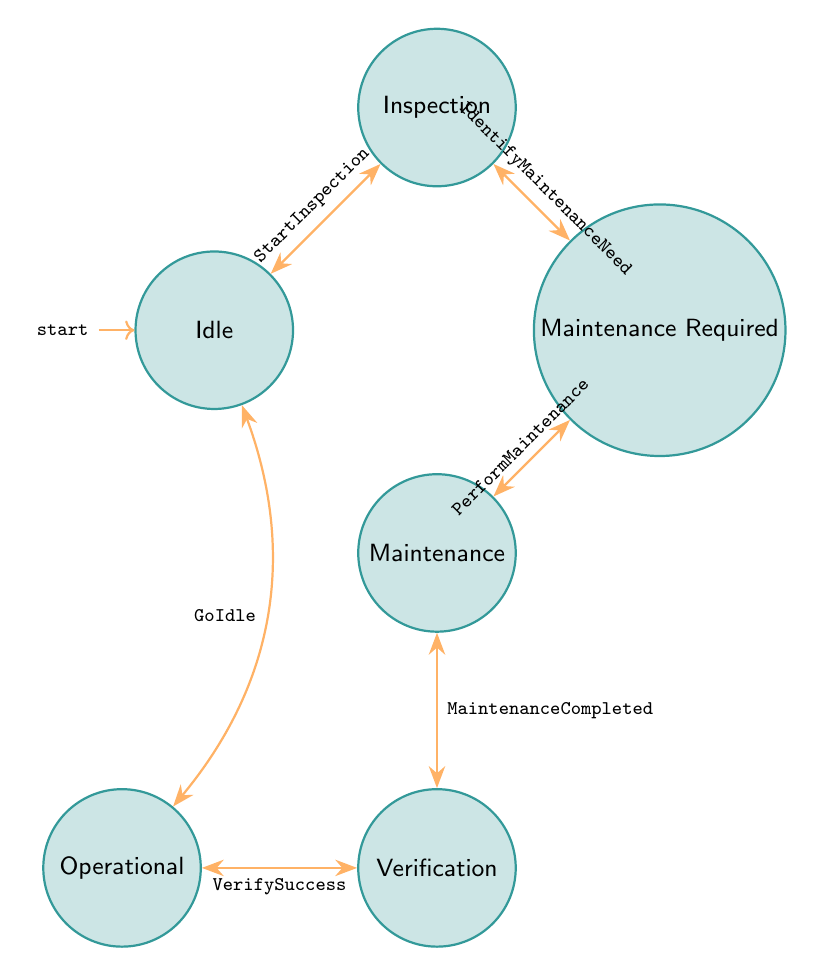What is the initial state in the diagram? The initial state is indicated by the label 'initial' in the diagram. The node labeled 'Idle' has this designation, showing that it is the starting point for the state transitions.
Answer: Idle How many total states are present in the diagram? The states are listed in the data under the 'states' section. By counting each individual state mentioned, we find there are six states: Idle, Inspection, Maintenance Required, Maintenance, Verification, and Operational.
Answer: Six What transition occurs after 'Inspection'? The transition from 'Inspection' leads to 'Maintenance Required' as shown in the data's transitions section that links these two states directly with the label 'IdentifyMaintenanceNeed'.
Answer: Maintenance Required What state follows 'Maintenance'? After 'Maintenance', the next state is 'Verification', as indicated by the transition labeled 'MaintenanceCompleted' that connects these two states in the diagram.
Answer: Verification What is the final state before going back to 'Idle'? The final state before returning to 'Idle' is 'Operational'. The transition labeled 'GoIdle' indicates that the process can revert to the 'Idle' state from 'Operational'.
Answer: Operational What is the relationship between 'MaintenanceRequired' and 'Maintenance'? The relationship is a direct transition where 'MaintenanceRequired' leads to 'Maintenance'. The transition labeled 'PerformMaintenance' defines this connection.
Answer: Maintenance Which state indicates that equipment is functioning as expected? The state that signifies that equipment is functioning correctly after all necessary procedures is 'Operational', as per the definitions provided for the states.
Answer: Operational What transition indicates the start of the maintenance process? The transition that marks the beginning of the maintenance process is 'PerformMaintenance', which occurs after 'MaintenanceRequired' signals that maintenance is needed.
Answer: PerformMaintenance What state signifies that no action is currently being taken? The state labeled 'Idle' signifies that no action is currently being performed on the equipment and it is awaiting either inspection or maintenance.
Answer: Idle 